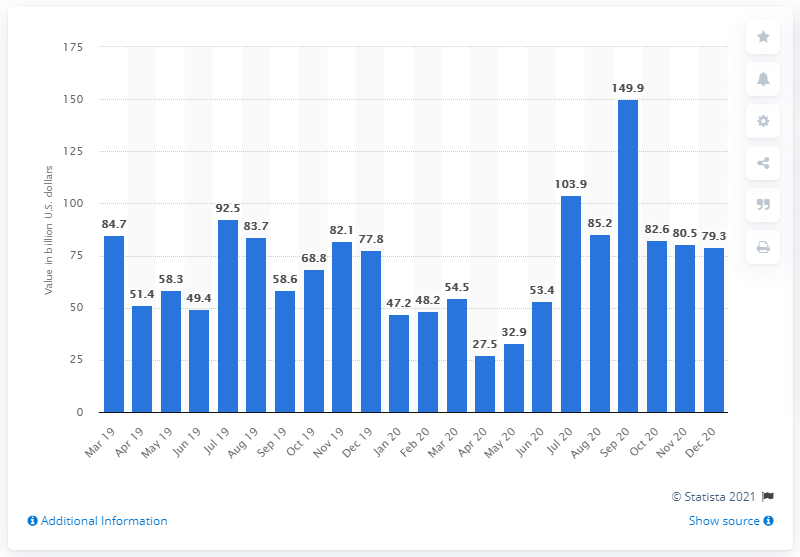Outline some significant characteristics in this image. There were 80.5 deals in M&A transactions in Asia in December of 2020. The value of M&A deals in Asia in December 2020 was 79.3... 